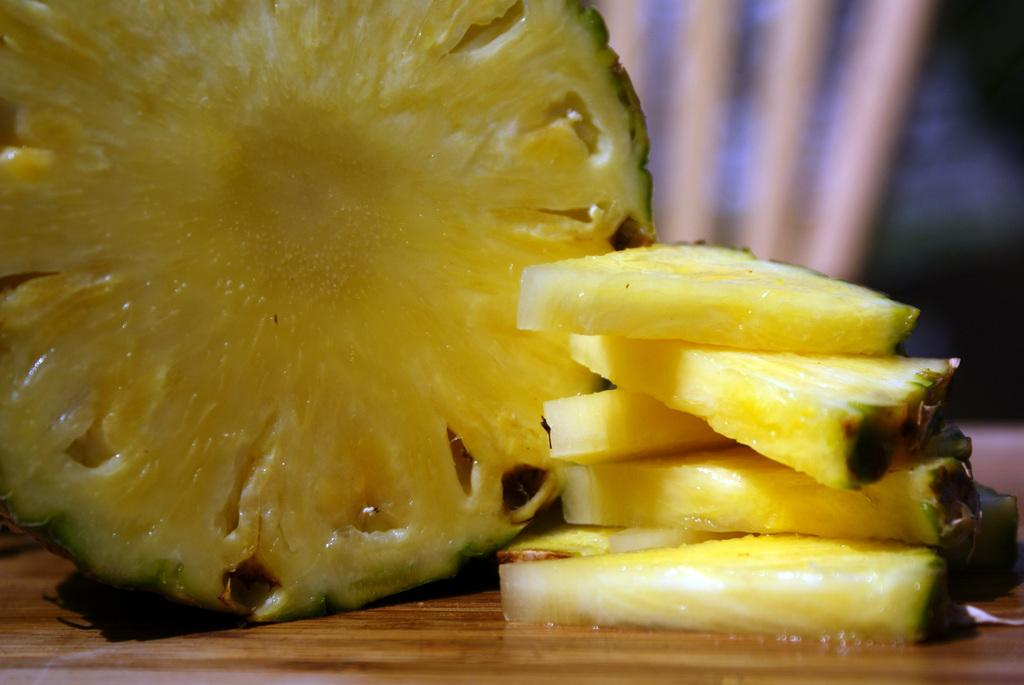What is located at the bottom of the image? There is a table at the bottom of the image. What is on the table in the image? There is a pineapple on the table. Are there any additional pineapple-related items on the table? Yes, there are pieces of pineapple on the table. What type of pot is visible on the table in the image? There is no pot visible on the table in the image; it only features a pineapple and pieces of pineapple. 